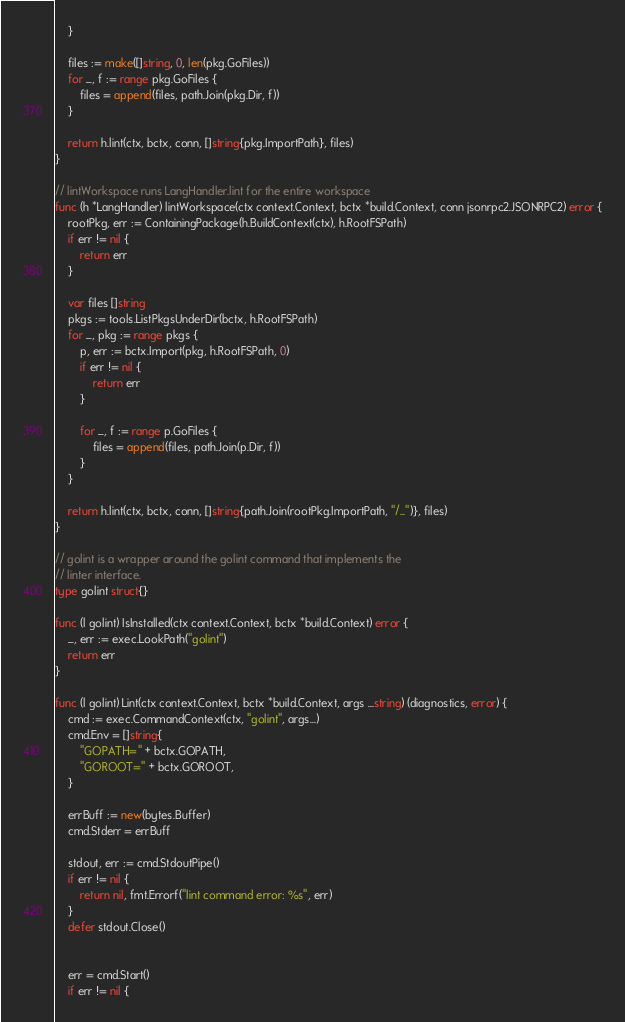Convert code to text. <code><loc_0><loc_0><loc_500><loc_500><_Go_>	}

	files := make([]string, 0, len(pkg.GoFiles))
	for _, f := range pkg.GoFiles {
		files = append(files, path.Join(pkg.Dir, f))
	}

	return h.lint(ctx, bctx, conn, []string{pkg.ImportPath}, files)
}

// lintWorkspace runs LangHandler.lint for the entire workspace
func (h *LangHandler) lintWorkspace(ctx context.Context, bctx *build.Context, conn jsonrpc2.JSONRPC2) error {
	rootPkg, err := ContainingPackage(h.BuildContext(ctx), h.RootFSPath)
	if err != nil {
		return err
	}

	var files []string
	pkgs := tools.ListPkgsUnderDir(bctx, h.RootFSPath)
	for _, pkg := range pkgs {
		p, err := bctx.Import(pkg, h.RootFSPath, 0)
		if err != nil {
			return err
		}

		for _, f := range p.GoFiles {
			files = append(files, path.Join(p.Dir, f))
		}
	}

	return h.lint(ctx, bctx, conn, []string{path.Join(rootPkg.ImportPath, "/...")}, files)
}

// golint is a wrapper around the golint command that implements the
// linter interface.
type golint struct{}

func (l golint) IsInstalled(ctx context.Context, bctx *build.Context) error {
	_, err := exec.LookPath("golint")
	return err
}

func (l golint) Lint(ctx context.Context, bctx *build.Context, args ...string) (diagnostics, error) {
	cmd := exec.CommandContext(ctx, "golint", args...)
	cmd.Env = []string{
		"GOPATH=" + bctx.GOPATH,
		"GOROOT=" + bctx.GOROOT,
	}

	errBuff := new(bytes.Buffer)
	cmd.Stderr = errBuff

	stdout, err := cmd.StdoutPipe()
	if err != nil {
		return nil, fmt.Errorf("lint command error: %s", err)
	}
	defer stdout.Close()


	err = cmd.Start()
	if err != nil {</code> 